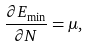<formula> <loc_0><loc_0><loc_500><loc_500>\frac { \partial E _ { \min } } { \partial N } = \mu ,</formula> 